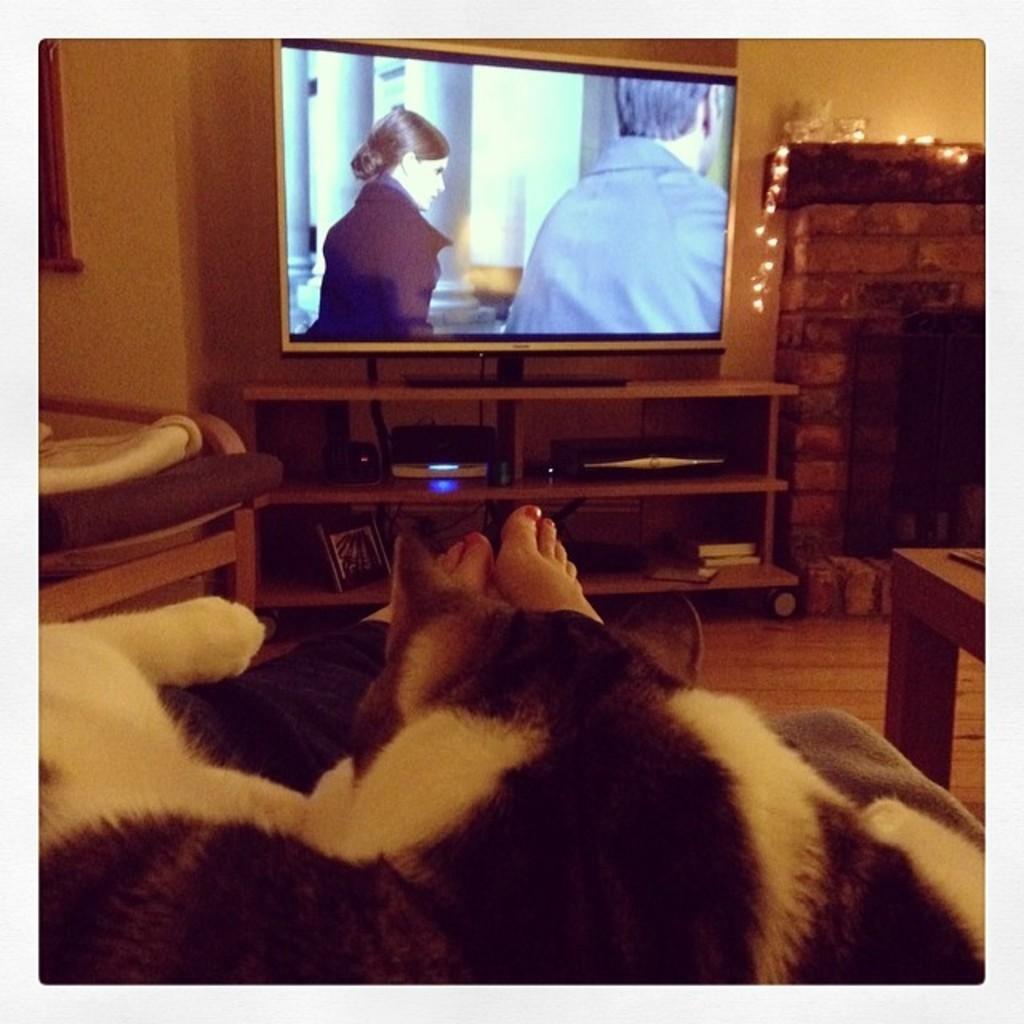Describe this image in one or two sentences. In the image there is cat slept on legs of a person. In the front there is tv ,down its player and books In shelf. On beside that there is firewood chimney tunnel. 